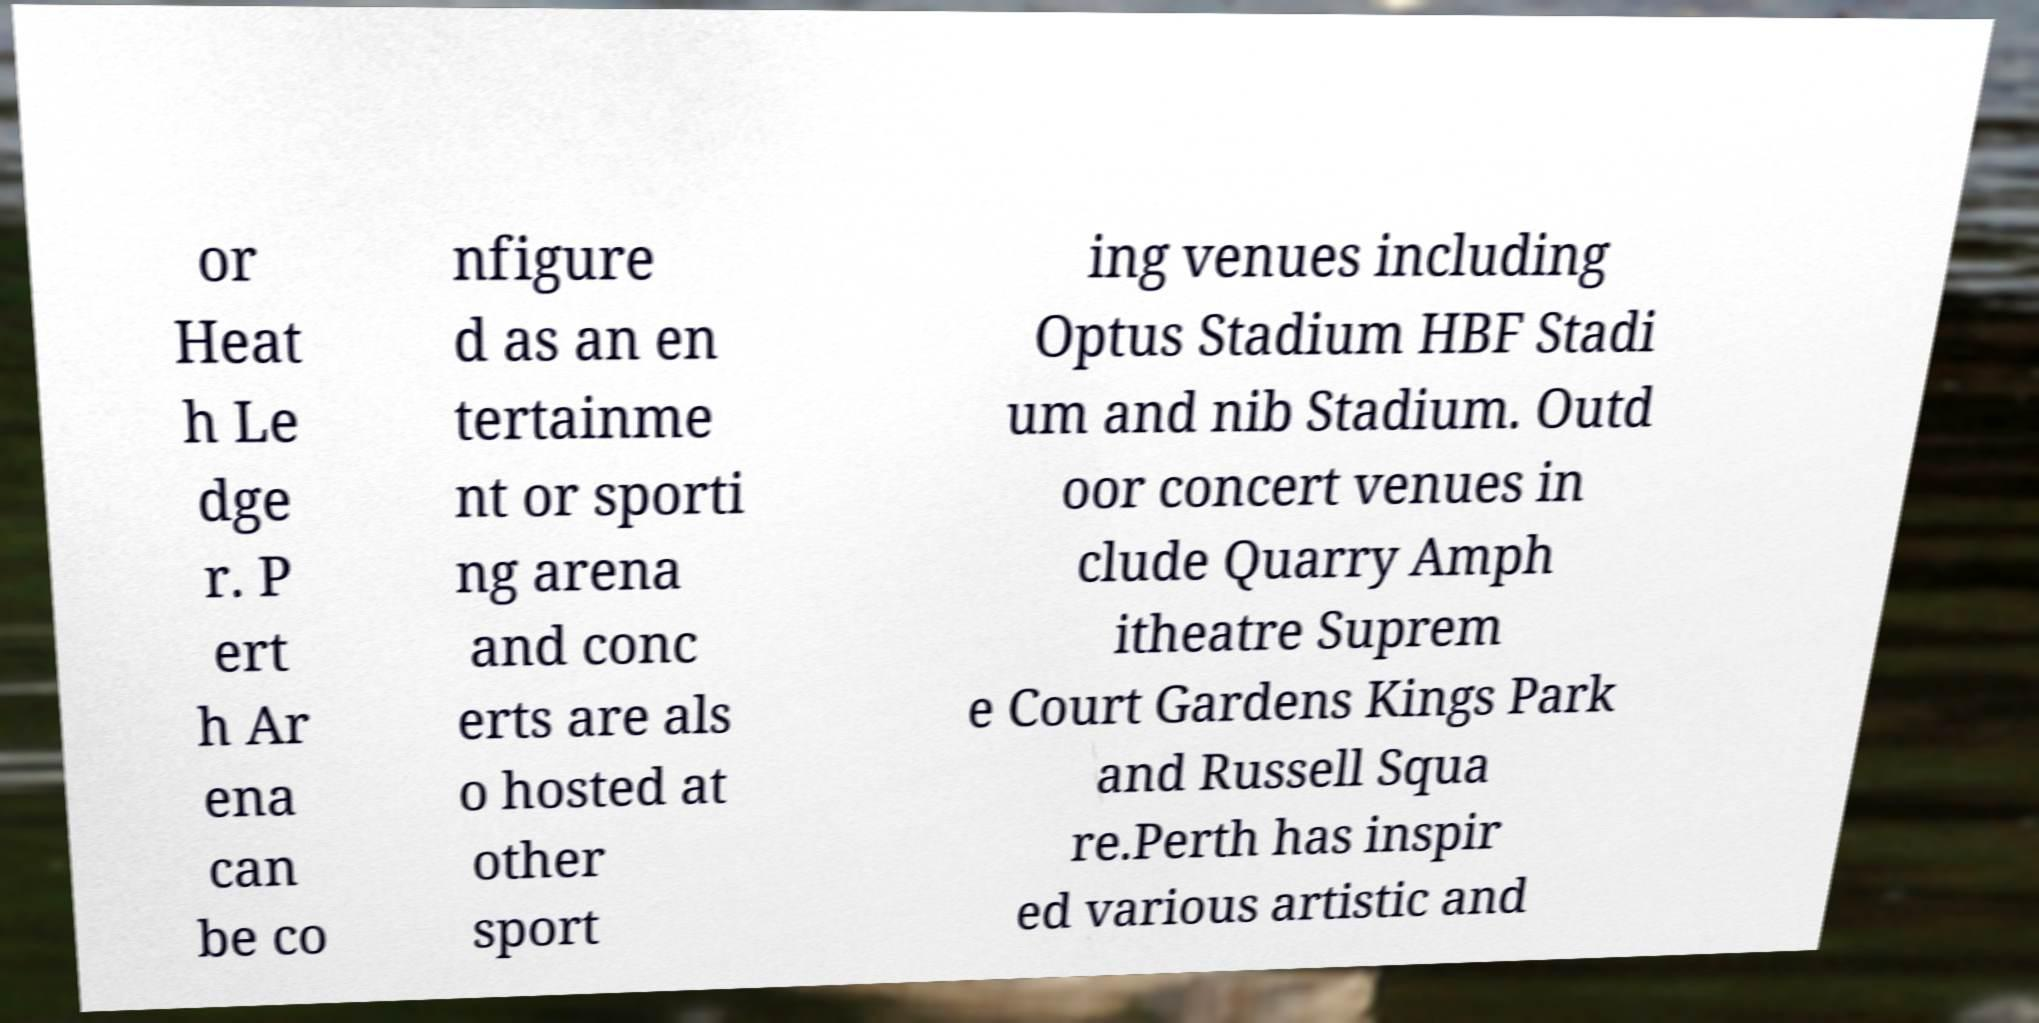Can you read and provide the text displayed in the image?This photo seems to have some interesting text. Can you extract and type it out for me? or Heat h Le dge r. P ert h Ar ena can be co nfigure d as an en tertainme nt or sporti ng arena and conc erts are als o hosted at other sport ing venues including Optus Stadium HBF Stadi um and nib Stadium. Outd oor concert venues in clude Quarry Amph itheatre Suprem e Court Gardens Kings Park and Russell Squa re.Perth has inspir ed various artistic and 